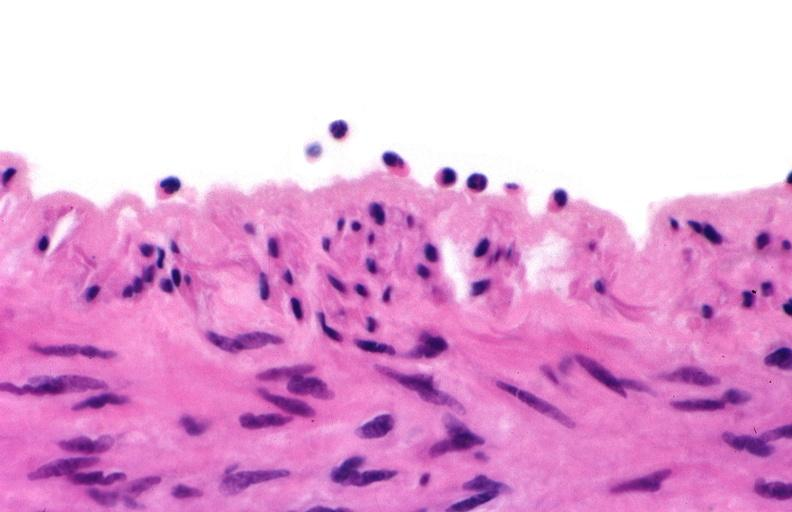where is this from?
Answer the question using a single word or phrase. Vasculature 